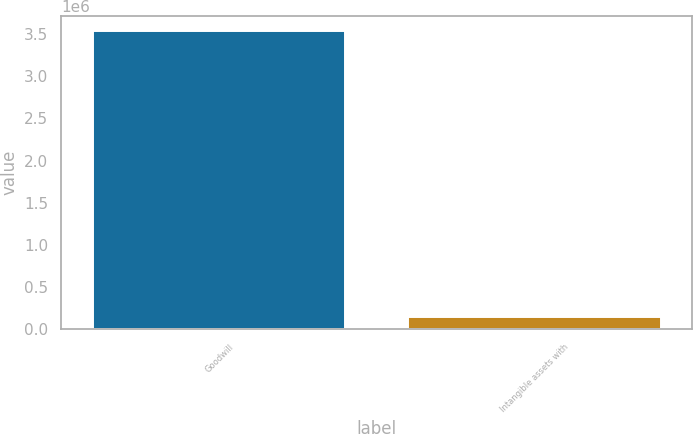<chart> <loc_0><loc_0><loc_500><loc_500><bar_chart><fcel>Goodwill<fcel>Intangible assets with<nl><fcel>3.53857e+06<fcel>143878<nl></chart> 